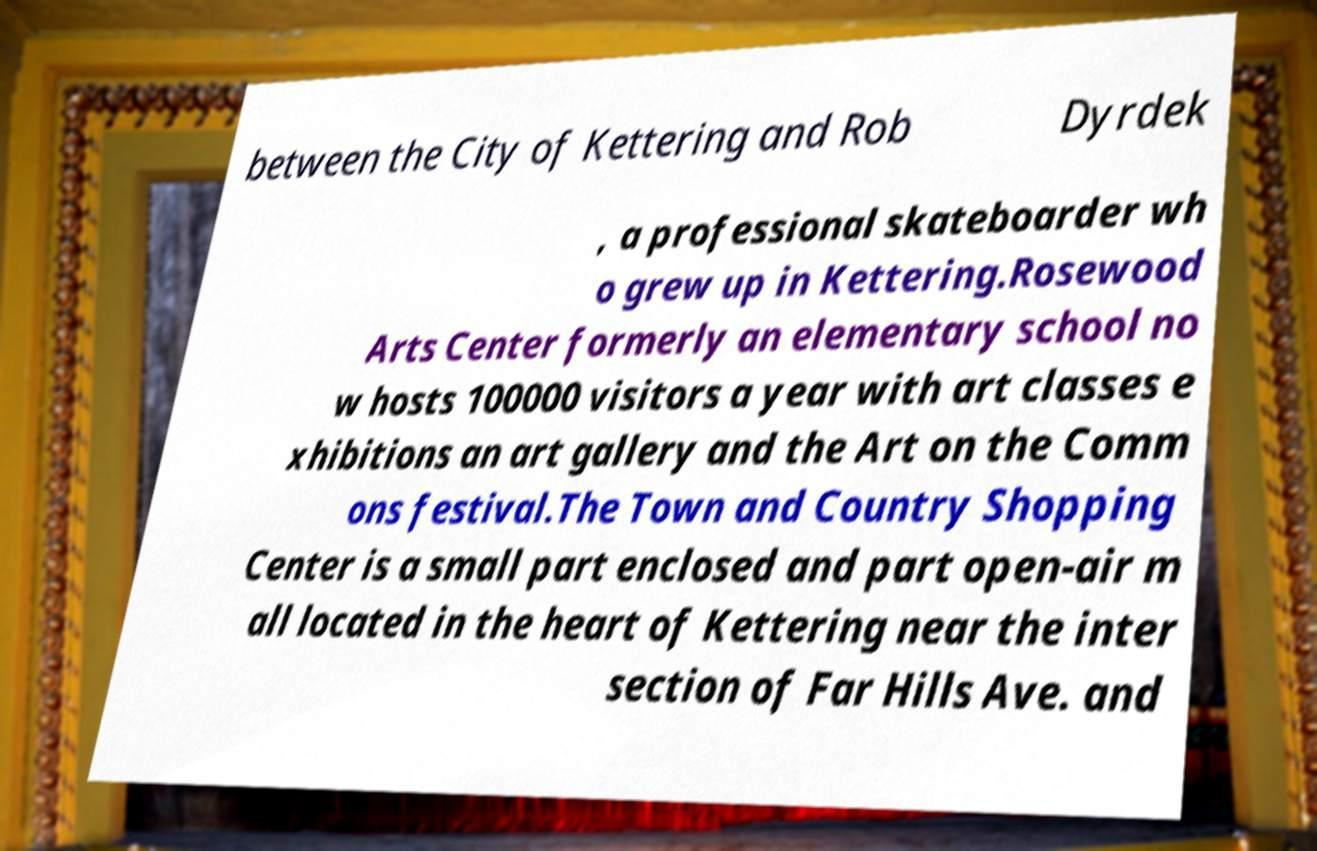Can you accurately transcribe the text from the provided image for me? between the City of Kettering and Rob Dyrdek , a professional skateboarder wh o grew up in Kettering.Rosewood Arts Center formerly an elementary school no w hosts 100000 visitors a year with art classes e xhibitions an art gallery and the Art on the Comm ons festival.The Town and Country Shopping Center is a small part enclosed and part open-air m all located in the heart of Kettering near the inter section of Far Hills Ave. and 